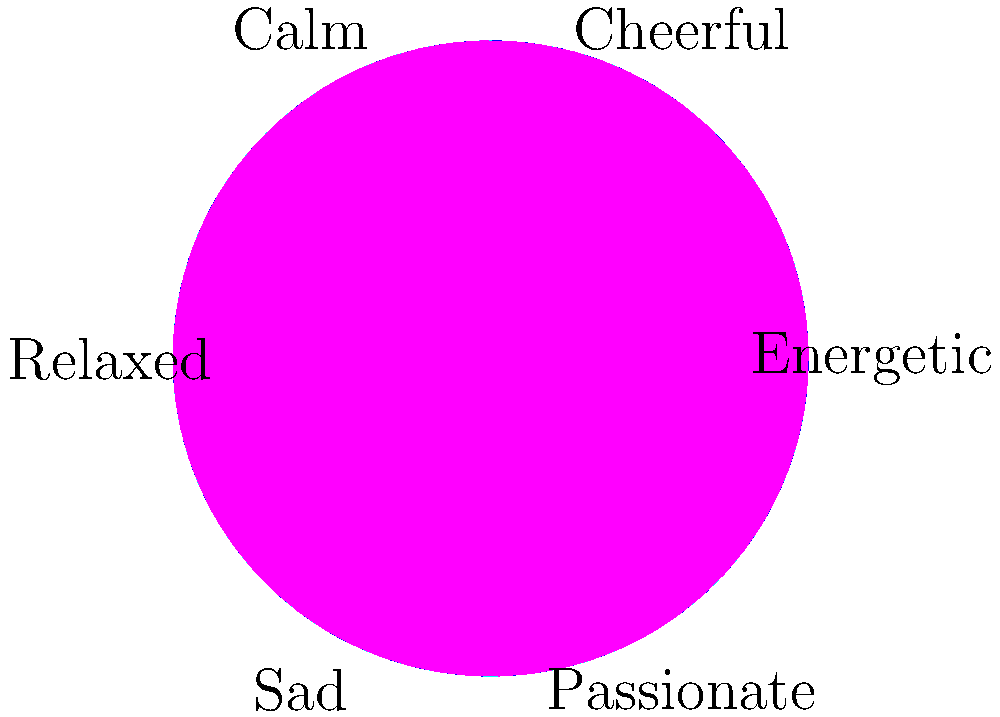Based on the color wheel and associated mood descriptors, which psychological principle best explains the relationship between colors and emotions, and how might this understanding be applied in therapeutic settings? To answer this question, let's break down the key concepts and their applications:

1. Color-Emotion Association: The color wheel shows specific emotions tied to different colors. This reflects the psychological principle of color-mood association.

2. Emotional Continuum: The arrangement of emotions on the wheel suggests a continuum, transitioning from high-energy emotions (e.g., "Energetic") to low-energy emotions (e.g., "Relaxed").

3. Complementary Colors and Emotions: Opposite colors on the wheel are associated with contrasting emotions (e.g., "Energetic" red vs. "Relaxed" blue-green), demonstrating the principle of emotional balance.

4. Cultural Influence: While some color-emotion associations may be universal, cultural factors can influence these relationships, highlighting the importance of cultural context in color psychology.

5. Therapeutic Application: Understanding these associations allows for the strategic use of color in therapy:
   a) Color-based mood induction for emotional regulation
   b) Creating supportive environments through color choices
   c) Using color preferences as a diagnostic tool for emotional states

6. Cognitive-Behavioral Connection: The link between colors and emotions suggests a cognitive component to emotional experiences, aligning with cognitive-behavioral therapy principles.

7. Mimetic Experience: The visual representation of emotions through colors creates a mimetic experience, allowing individuals to externalize and process their emotions more effectively.

The psychological principle that best explains this relationship is the "Associative Learning Theory in Color Psychology," which posits that colors evoke emotional responses due to learned associations and experiences.

In therapeutic settings, this understanding can be applied through color therapy techniques, environmental design in clinical spaces, and as a tool for emotional assessment and expression in various psychotherapeutic approaches.
Answer: Associative Learning Theory in Color Psychology; applied through color therapy, environmental design, and emotional assessment tools. 